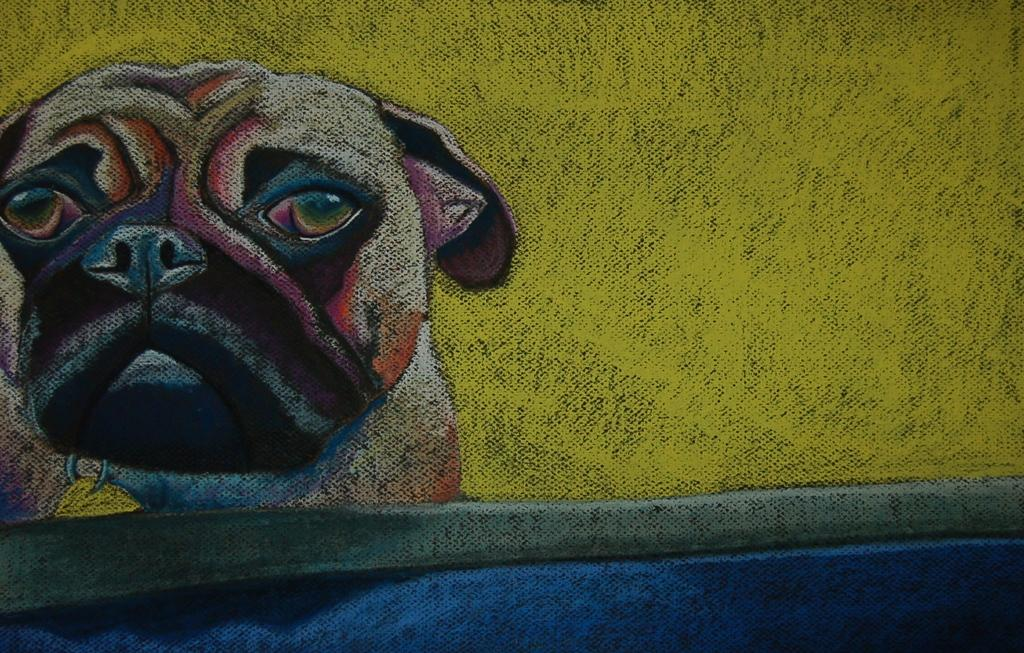What is the main subject of the image? There is a painting in the image. What is depicted in the painting? The painting depicts a dog. On what surface is the painting placed? The painting is on a surface. How many birds are flying in the painting? There are no birds present in the painting; it depicts a dog. What type of shoes is the dog wearing in the painting? The painting does not show the dog wearing any shoes. 